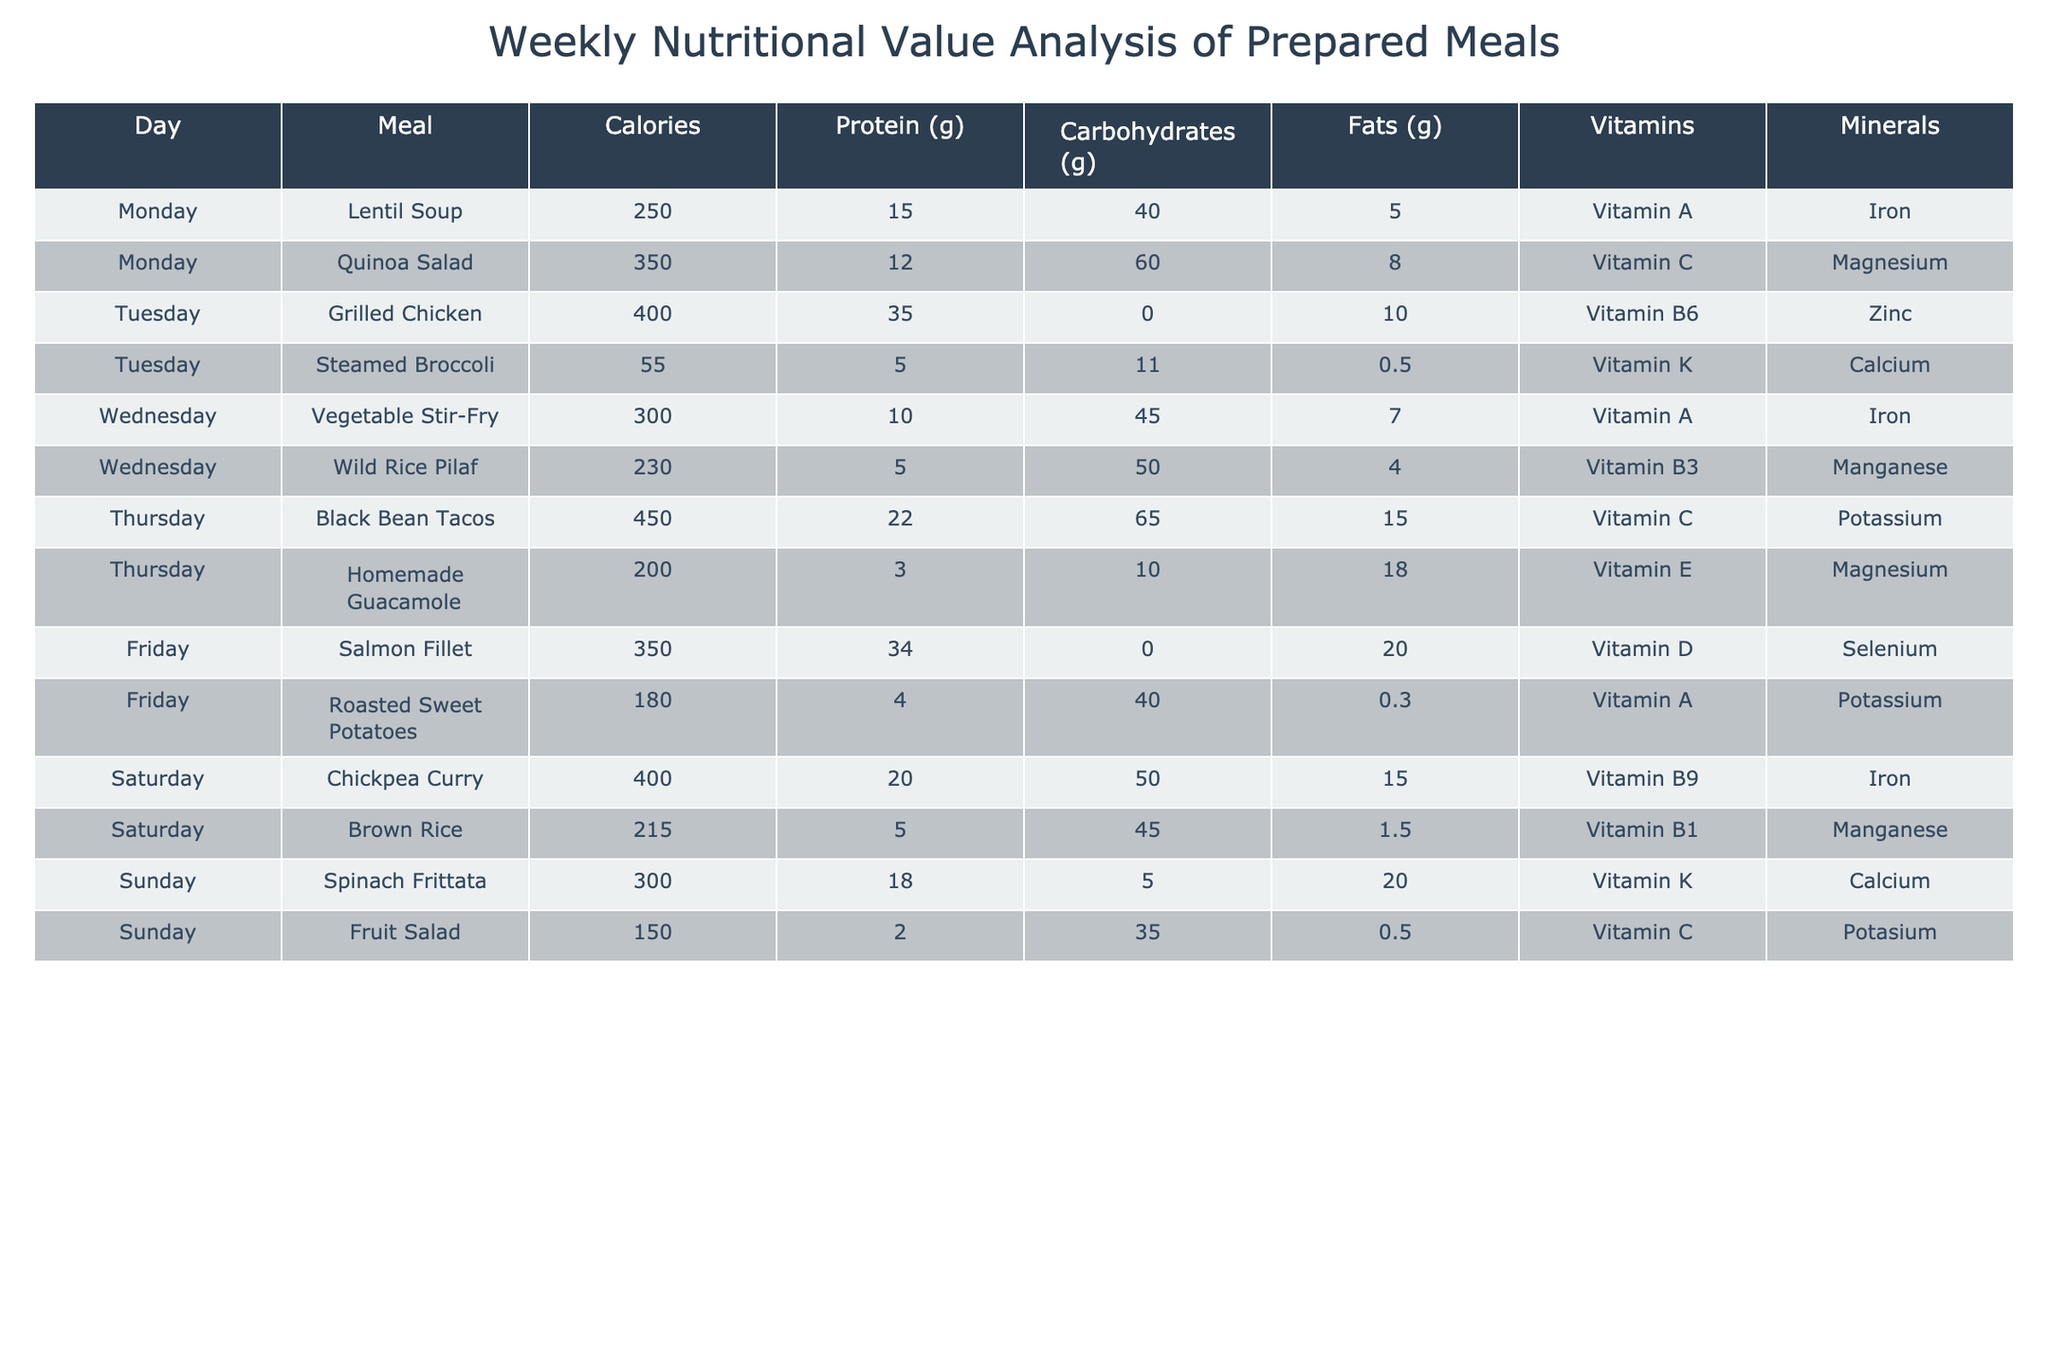What is the total calorie count for meals served on Tuesday? For Tuesday, the meals are Grilled Chicken (400 calories) and Steamed Broccoli (55 calories). Adding these together gives us 400 + 55 = 455 calories.
Answer: 455 Which meal has the highest protein content, and how much is it? The meal with the highest protein content is Grilled Chicken, which has 35 grams of protein.
Answer: Grilled Chicken, 35 grams On which day is a meal that contains Vitamin E served? The meal containing Vitamin E is Homemade Guacamole, which is served on Thursday.
Answer: Thursday What is the average fat content of the meals served on Saturday? The meals on Saturday are Chickpea Curry (15g fat) and Brown Rice (1.5g fat). To find the average, we calculate (15 + 1.5) / 2 = 8.25 grams of fat.
Answer: 8.25 grams Is there a meal served on Sunday that contains both protein and carbohydrates? Yes, both Spinach Frittata (18g protein, 5g carbohydrates) and Fruit Salad (2g protein, 35g carbohydrates) serve on Sunday contain protein and carbohydrates.
Answer: Yes How much total carbohydrate content do the meals served on Monday have? The meals on Monday are Lentil Soup (40g carbohydrates) and Quinoa Salad (60g carbohydrates). Adding the carbohydrate content gives us 40 + 60 = 100 grams.
Answer: 100 grams Which meal serves the least calories and what is the calorie count? The meal with the least calories is Steamed Broccoli, with only 55 calories.
Answer: Steamed Broccoli, 55 calories What percentage of the total calories from meals served on Thursday comes from Black Bean Tacos? The total calories for Thursday are Black Bean Tacos (450 calories) and Homemade Guacamole (200 calories), sum them to get 450 + 200 = 650 calories. The percentage from Black Bean Tacos is (450 / 650) * 100 ≈ 69.23%.
Answer: Approximately 69.23% Which meal served on Wednesday has more carbohydrates than protein? The Vegetable Stir-Fry has 45 grams of carbohydrates and only 10 grams of protein, indicating it contains more carbohydrates than protein.
Answer: Vegetable Stir-Fry 